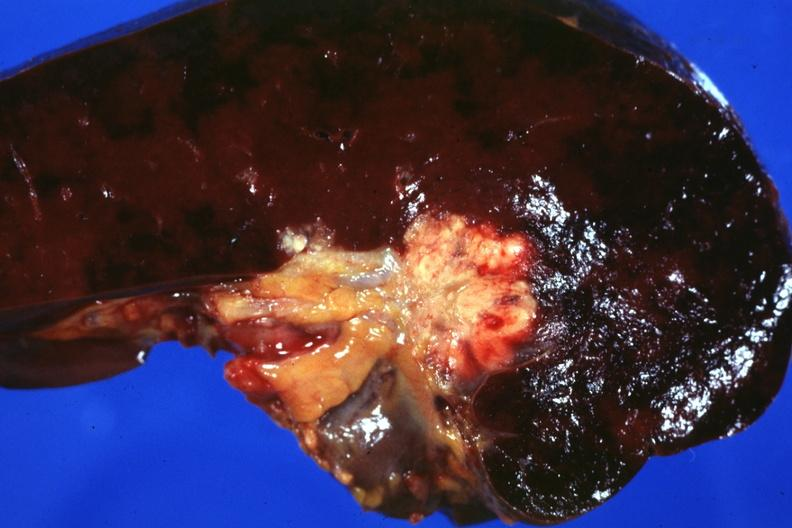where is this part in?
Answer the question using a single word or phrase. Spleen 